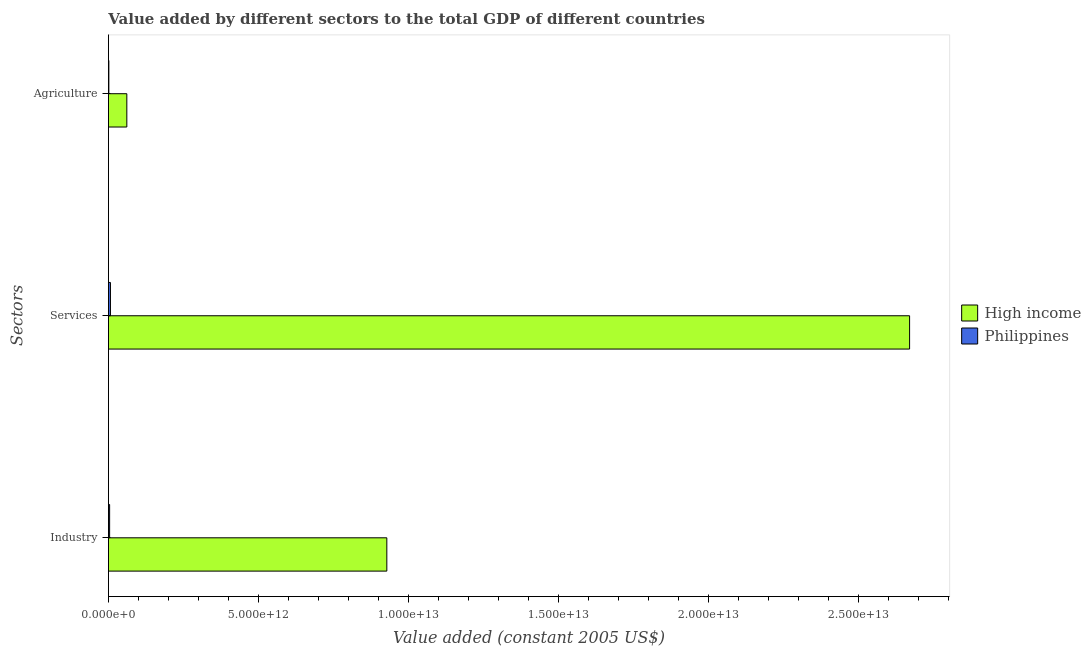How many different coloured bars are there?
Your answer should be very brief. 2. Are the number of bars per tick equal to the number of legend labels?
Give a very brief answer. Yes. Are the number of bars on each tick of the Y-axis equal?
Your answer should be compact. Yes. How many bars are there on the 1st tick from the top?
Your response must be concise. 2. What is the label of the 3rd group of bars from the top?
Keep it short and to the point. Industry. What is the value added by services in High income?
Your answer should be compact. 2.67e+13. Across all countries, what is the maximum value added by agricultural sector?
Offer a very short reply. 6.13e+11. Across all countries, what is the minimum value added by industrial sector?
Offer a very short reply. 3.97e+1. What is the total value added by services in the graph?
Your answer should be compact. 2.68e+13. What is the difference between the value added by agricultural sector in Philippines and that in High income?
Provide a short and direct response. -5.99e+11. What is the difference between the value added by agricultural sector in High income and the value added by industrial sector in Philippines?
Give a very brief answer. 5.74e+11. What is the average value added by services per country?
Ensure brevity in your answer.  1.34e+13. What is the difference between the value added by agricultural sector and value added by industrial sector in Philippines?
Ensure brevity in your answer.  -2.51e+1. In how many countries, is the value added by services greater than 17000000000000 US$?
Offer a very short reply. 1. What is the ratio of the value added by services in High income to that in Philippines?
Ensure brevity in your answer.  394.85. Is the difference between the value added by industrial sector in High income and Philippines greater than the difference between the value added by agricultural sector in High income and Philippines?
Give a very brief answer. Yes. What is the difference between the highest and the second highest value added by services?
Your answer should be compact. 2.66e+13. What is the difference between the highest and the lowest value added by industrial sector?
Make the answer very short. 9.24e+12. Is it the case that in every country, the sum of the value added by industrial sector and value added by services is greater than the value added by agricultural sector?
Offer a very short reply. Yes. Are all the bars in the graph horizontal?
Keep it short and to the point. Yes. What is the difference between two consecutive major ticks on the X-axis?
Provide a short and direct response. 5.00e+12. Are the values on the major ticks of X-axis written in scientific E-notation?
Your response must be concise. Yes. Does the graph contain any zero values?
Offer a very short reply. No. Where does the legend appear in the graph?
Provide a short and direct response. Center right. What is the title of the graph?
Your response must be concise. Value added by different sectors to the total GDP of different countries. Does "Slovenia" appear as one of the legend labels in the graph?
Provide a succinct answer. No. What is the label or title of the X-axis?
Your answer should be compact. Value added (constant 2005 US$). What is the label or title of the Y-axis?
Your answer should be very brief. Sectors. What is the Value added (constant 2005 US$) of High income in Industry?
Your answer should be very brief. 9.28e+12. What is the Value added (constant 2005 US$) of Philippines in Industry?
Your response must be concise. 3.97e+1. What is the Value added (constant 2005 US$) in High income in Services?
Provide a short and direct response. 2.67e+13. What is the Value added (constant 2005 US$) in Philippines in Services?
Ensure brevity in your answer.  6.76e+1. What is the Value added (constant 2005 US$) in High income in Agriculture?
Offer a terse response. 6.13e+11. What is the Value added (constant 2005 US$) of Philippines in Agriculture?
Keep it short and to the point. 1.45e+1. Across all Sectors, what is the maximum Value added (constant 2005 US$) of High income?
Your answer should be very brief. 2.67e+13. Across all Sectors, what is the maximum Value added (constant 2005 US$) in Philippines?
Offer a very short reply. 6.76e+1. Across all Sectors, what is the minimum Value added (constant 2005 US$) of High income?
Ensure brevity in your answer.  6.13e+11. Across all Sectors, what is the minimum Value added (constant 2005 US$) of Philippines?
Provide a short and direct response. 1.45e+1. What is the total Value added (constant 2005 US$) in High income in the graph?
Provide a short and direct response. 3.66e+13. What is the total Value added (constant 2005 US$) of Philippines in the graph?
Offer a very short reply. 1.22e+11. What is the difference between the Value added (constant 2005 US$) in High income in Industry and that in Services?
Keep it short and to the point. -1.74e+13. What is the difference between the Value added (constant 2005 US$) of Philippines in Industry and that in Services?
Make the answer very short. -2.80e+1. What is the difference between the Value added (constant 2005 US$) of High income in Industry and that in Agriculture?
Your answer should be very brief. 8.67e+12. What is the difference between the Value added (constant 2005 US$) of Philippines in Industry and that in Agriculture?
Provide a short and direct response. 2.51e+1. What is the difference between the Value added (constant 2005 US$) of High income in Services and that in Agriculture?
Provide a succinct answer. 2.61e+13. What is the difference between the Value added (constant 2005 US$) in Philippines in Services and that in Agriculture?
Your response must be concise. 5.31e+1. What is the difference between the Value added (constant 2005 US$) of High income in Industry and the Value added (constant 2005 US$) of Philippines in Services?
Give a very brief answer. 9.21e+12. What is the difference between the Value added (constant 2005 US$) in High income in Industry and the Value added (constant 2005 US$) in Philippines in Agriculture?
Make the answer very short. 9.26e+12. What is the difference between the Value added (constant 2005 US$) of High income in Services and the Value added (constant 2005 US$) of Philippines in Agriculture?
Keep it short and to the point. 2.67e+13. What is the average Value added (constant 2005 US$) of High income per Sectors?
Ensure brevity in your answer.  1.22e+13. What is the average Value added (constant 2005 US$) of Philippines per Sectors?
Provide a succinct answer. 4.06e+1. What is the difference between the Value added (constant 2005 US$) in High income and Value added (constant 2005 US$) in Philippines in Industry?
Offer a very short reply. 9.24e+12. What is the difference between the Value added (constant 2005 US$) in High income and Value added (constant 2005 US$) in Philippines in Services?
Ensure brevity in your answer.  2.66e+13. What is the difference between the Value added (constant 2005 US$) of High income and Value added (constant 2005 US$) of Philippines in Agriculture?
Your response must be concise. 5.99e+11. What is the ratio of the Value added (constant 2005 US$) in High income in Industry to that in Services?
Provide a short and direct response. 0.35. What is the ratio of the Value added (constant 2005 US$) of Philippines in Industry to that in Services?
Ensure brevity in your answer.  0.59. What is the ratio of the Value added (constant 2005 US$) in High income in Industry to that in Agriculture?
Your answer should be compact. 15.13. What is the ratio of the Value added (constant 2005 US$) in Philippines in Industry to that in Agriculture?
Keep it short and to the point. 2.73. What is the ratio of the Value added (constant 2005 US$) of High income in Services to that in Agriculture?
Your response must be concise. 43.53. What is the ratio of the Value added (constant 2005 US$) in Philippines in Services to that in Agriculture?
Provide a short and direct response. 4.66. What is the difference between the highest and the second highest Value added (constant 2005 US$) of High income?
Make the answer very short. 1.74e+13. What is the difference between the highest and the second highest Value added (constant 2005 US$) of Philippines?
Ensure brevity in your answer.  2.80e+1. What is the difference between the highest and the lowest Value added (constant 2005 US$) in High income?
Make the answer very short. 2.61e+13. What is the difference between the highest and the lowest Value added (constant 2005 US$) of Philippines?
Offer a terse response. 5.31e+1. 